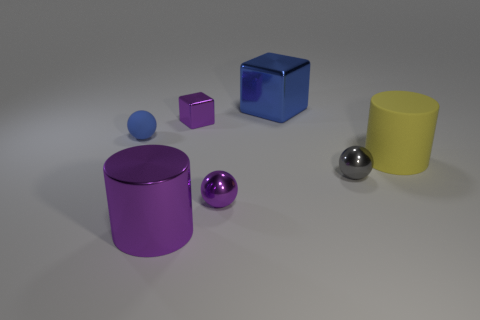Add 1 large green cylinders. How many objects exist? 8 Subtract all balls. How many objects are left? 4 Subtract all yellow matte objects. Subtract all shiny blocks. How many objects are left? 4 Add 5 small shiny things. How many small shiny things are left? 8 Add 5 blue matte balls. How many blue matte balls exist? 6 Subtract 1 purple balls. How many objects are left? 6 